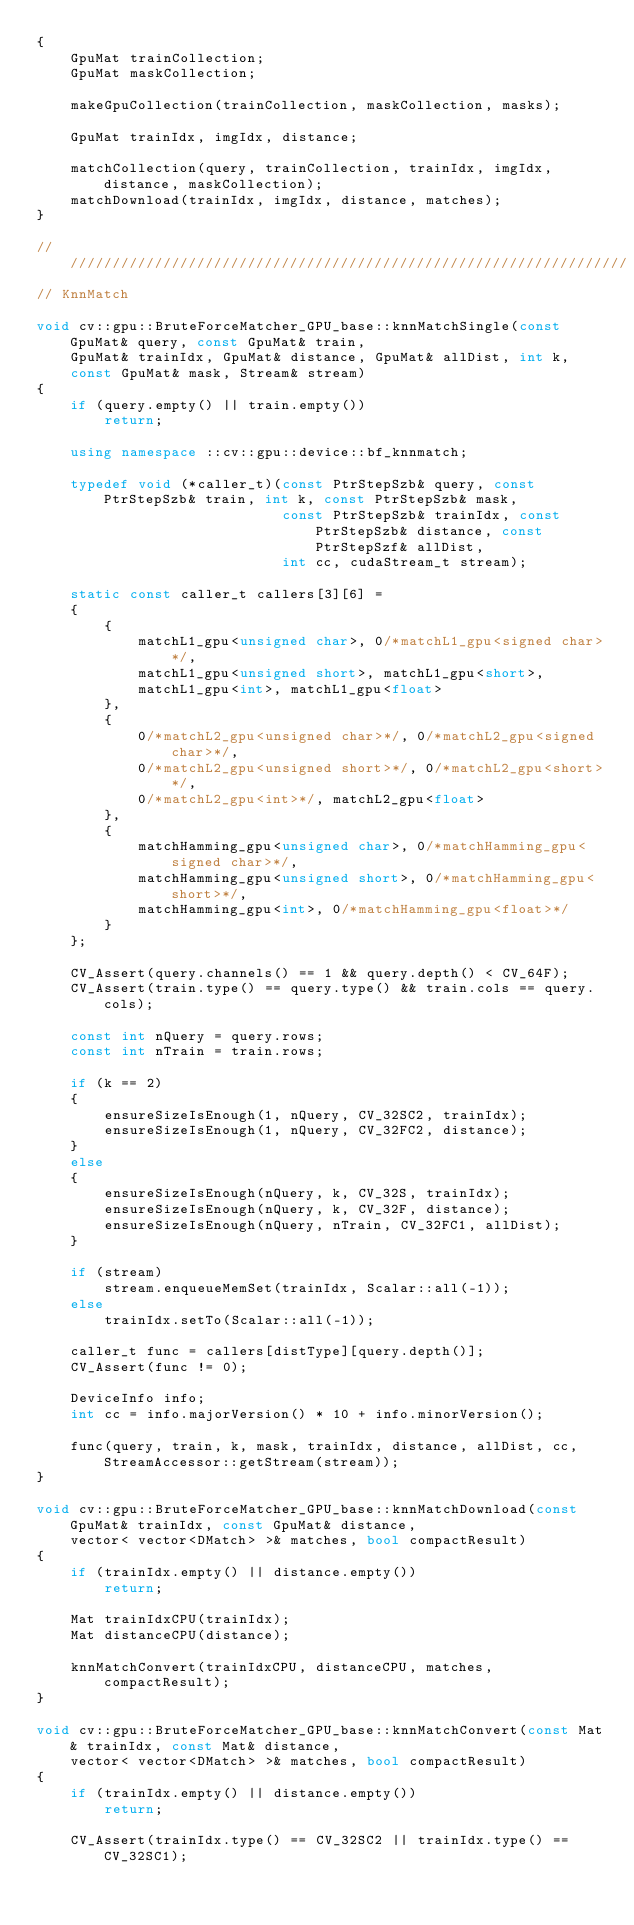<code> <loc_0><loc_0><loc_500><loc_500><_C++_>{
    GpuMat trainCollection;
    GpuMat maskCollection;

    makeGpuCollection(trainCollection, maskCollection, masks);

    GpuMat trainIdx, imgIdx, distance;

    matchCollection(query, trainCollection, trainIdx, imgIdx, distance, maskCollection);
    matchDownload(trainIdx, imgIdx, distance, matches);
}

////////////////////////////////////////////////////////////////////
// KnnMatch

void cv::gpu::BruteForceMatcher_GPU_base::knnMatchSingle(const GpuMat& query, const GpuMat& train,
    GpuMat& trainIdx, GpuMat& distance, GpuMat& allDist, int k,
    const GpuMat& mask, Stream& stream)
{
    if (query.empty() || train.empty())
        return;

    using namespace ::cv::gpu::device::bf_knnmatch;

    typedef void (*caller_t)(const PtrStepSzb& query, const PtrStepSzb& train, int k, const PtrStepSzb& mask,
                             const PtrStepSzb& trainIdx, const PtrStepSzb& distance, const PtrStepSzf& allDist,
                             int cc, cudaStream_t stream);

    static const caller_t callers[3][6] =
    {
        {
            matchL1_gpu<unsigned char>, 0/*matchL1_gpu<signed char>*/,
            matchL1_gpu<unsigned short>, matchL1_gpu<short>,
            matchL1_gpu<int>, matchL1_gpu<float>
        },
        {
            0/*matchL2_gpu<unsigned char>*/, 0/*matchL2_gpu<signed char>*/,
            0/*matchL2_gpu<unsigned short>*/, 0/*matchL2_gpu<short>*/,
            0/*matchL2_gpu<int>*/, matchL2_gpu<float>
        },
        {
            matchHamming_gpu<unsigned char>, 0/*matchHamming_gpu<signed char>*/,
            matchHamming_gpu<unsigned short>, 0/*matchHamming_gpu<short>*/,
            matchHamming_gpu<int>, 0/*matchHamming_gpu<float>*/
        }
    };

    CV_Assert(query.channels() == 1 && query.depth() < CV_64F);
    CV_Assert(train.type() == query.type() && train.cols == query.cols);

    const int nQuery = query.rows;
    const int nTrain = train.rows;

    if (k == 2)
    {
        ensureSizeIsEnough(1, nQuery, CV_32SC2, trainIdx);
        ensureSizeIsEnough(1, nQuery, CV_32FC2, distance);
    }
    else
    {
        ensureSizeIsEnough(nQuery, k, CV_32S, trainIdx);
        ensureSizeIsEnough(nQuery, k, CV_32F, distance);
        ensureSizeIsEnough(nQuery, nTrain, CV_32FC1, allDist);
    }

    if (stream)
        stream.enqueueMemSet(trainIdx, Scalar::all(-1));
    else
        trainIdx.setTo(Scalar::all(-1));

    caller_t func = callers[distType][query.depth()];
    CV_Assert(func != 0);

    DeviceInfo info;
    int cc = info.majorVersion() * 10 + info.minorVersion();

    func(query, train, k, mask, trainIdx, distance, allDist, cc, StreamAccessor::getStream(stream));
}

void cv::gpu::BruteForceMatcher_GPU_base::knnMatchDownload(const GpuMat& trainIdx, const GpuMat& distance,
    vector< vector<DMatch> >& matches, bool compactResult)
{
    if (trainIdx.empty() || distance.empty())
        return;

    Mat trainIdxCPU(trainIdx);
    Mat distanceCPU(distance);

    knnMatchConvert(trainIdxCPU, distanceCPU, matches, compactResult);
}

void cv::gpu::BruteForceMatcher_GPU_base::knnMatchConvert(const Mat& trainIdx, const Mat& distance,
    vector< vector<DMatch> >& matches, bool compactResult)
{
    if (trainIdx.empty() || distance.empty())
        return;

    CV_Assert(trainIdx.type() == CV_32SC2 || trainIdx.type() == CV_32SC1);</code> 